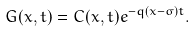<formula> <loc_0><loc_0><loc_500><loc_500>G ( x , t ) = C ( x , t ) e ^ { - q ( x - \sigma ) t } .</formula> 